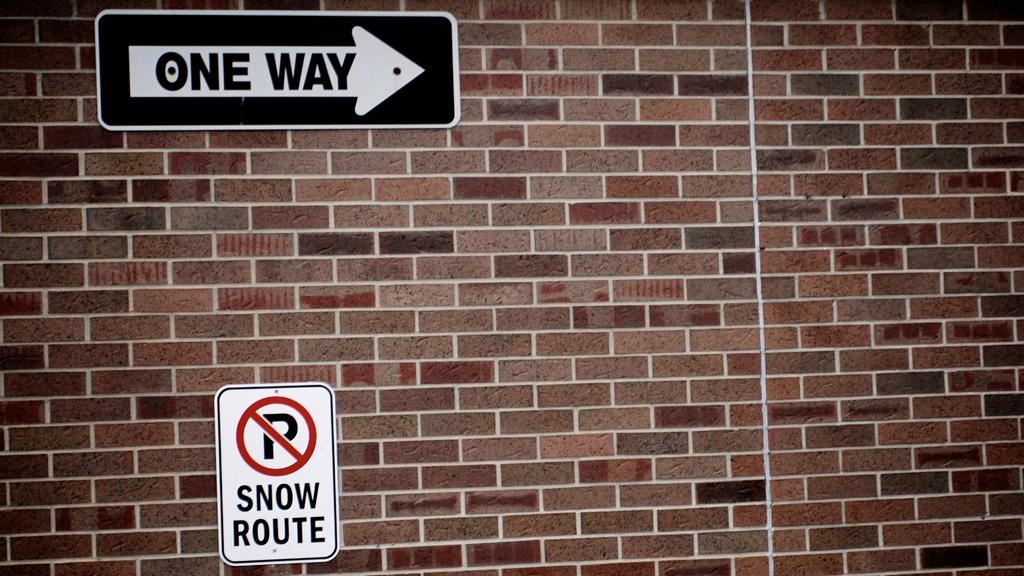Can you go two ways in this route?
Ensure brevity in your answer.  No. What type of route is mentioned on the sign with the white background?
Keep it short and to the point. Snow route. 